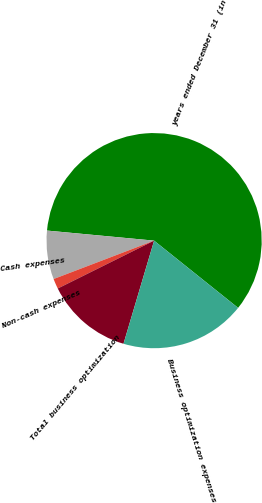Convert chart. <chart><loc_0><loc_0><loc_500><loc_500><pie_chart><fcel>years ended December 31 (in<fcel>Cash expenses<fcel>Non-cash expenses<fcel>Total business optimization<fcel>Business optimization expenses<nl><fcel>59.25%<fcel>7.3%<fcel>1.53%<fcel>13.07%<fcel>18.85%<nl></chart> 